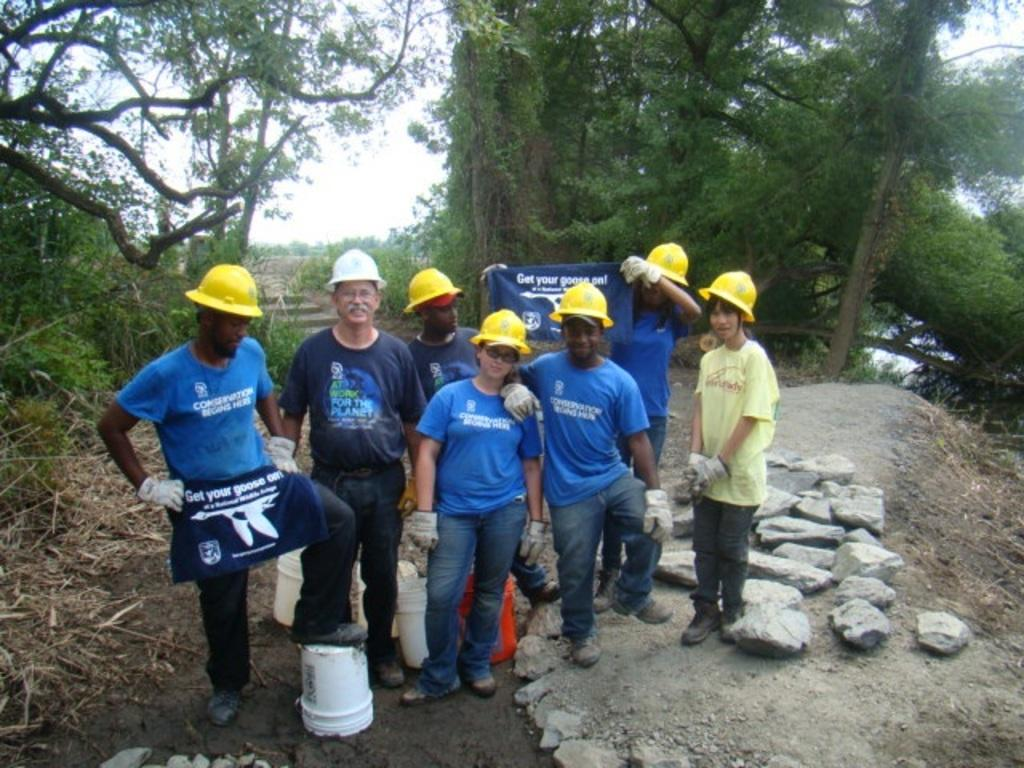<image>
Offer a succinct explanation of the picture presented. A group of people in yellow hard hats are holding shirts that say Get your goose on. 